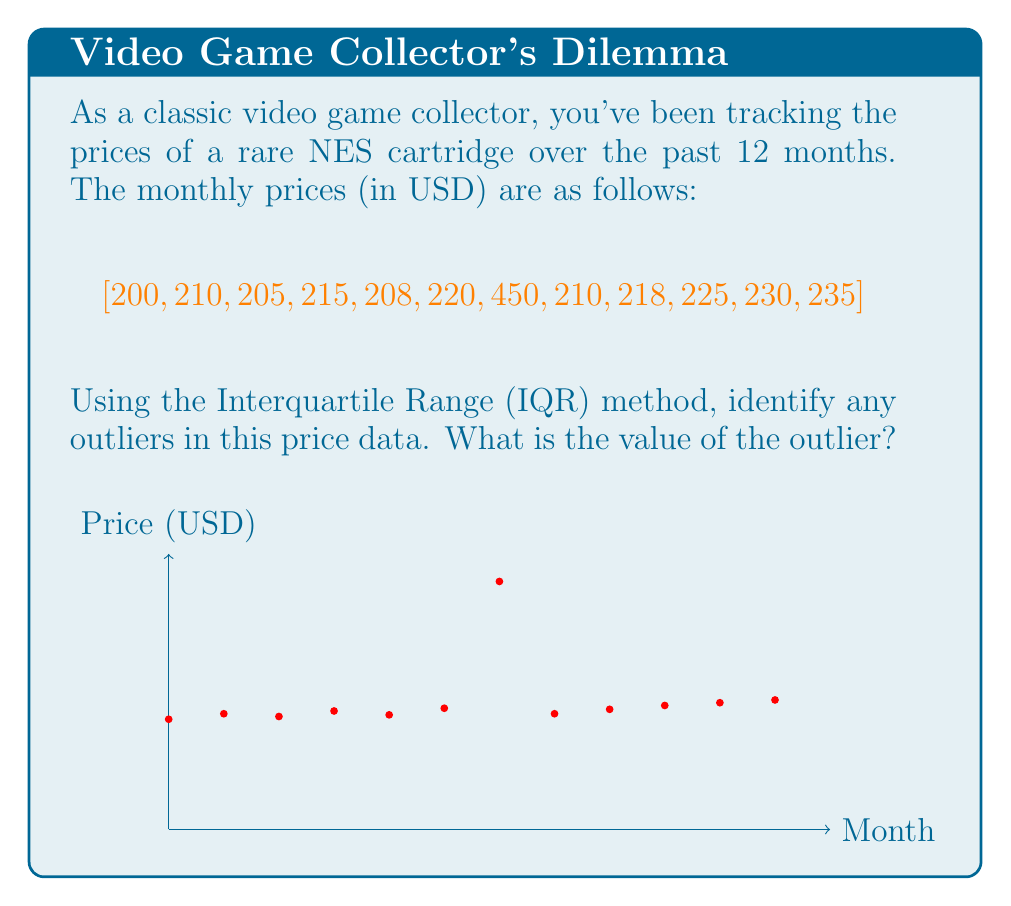Teach me how to tackle this problem. To identify outliers using the IQR method, we follow these steps:

1. Sort the data in ascending order:
   $$[200, 205, 208, 210, 210, 215, 218, 220, 225, 230, 235, 450]$$

2. Find Q1 (first quartile), Q2 (median), and Q3 (third quartile):
   Q1 = 208.75
   Q2 = 216.5
   Q3 = 226.25

3. Calculate the Interquartile Range (IQR):
   $$IQR = Q3 - Q1 = 226.25 - 208.75 = 17.5$$

4. Calculate the lower and upper bounds for outliers:
   Lower bound: $Q1 - 1.5 * IQR = 208.75 - 1.5 * 17.5 = 182.5$
   Upper bound: $Q3 + 1.5 * IQR = 226.25 + 1.5 * 17.5 = 252.5$

5. Identify any values outside these bounds:
   The only value outside these bounds is 450, which is above the upper bound.

Therefore, 450 is identified as an outlier in this dataset.
Answer: 450 